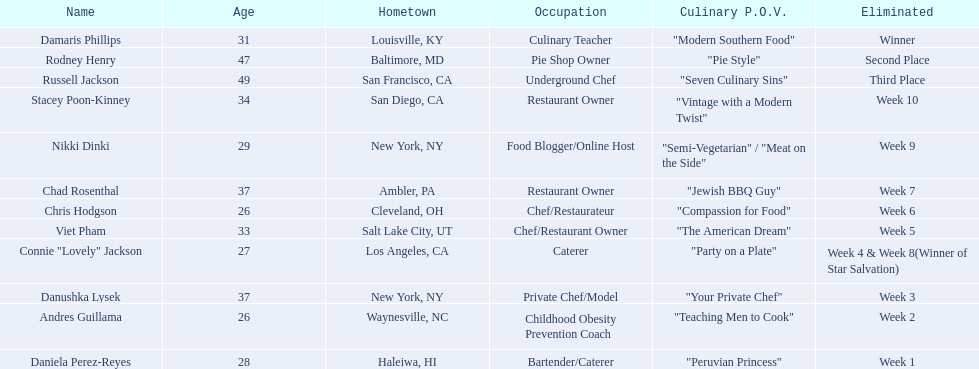Who was dismissed first, nikki dinki or viet pham? Viet Pham. 